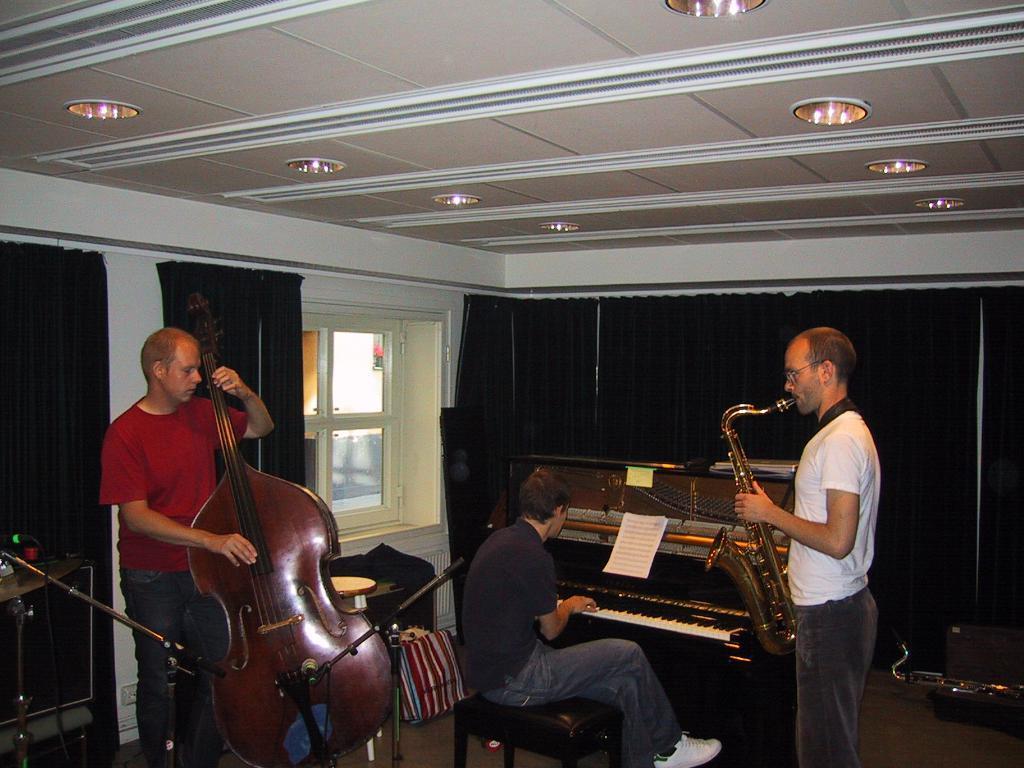How would you summarize this image in a sentence or two? In this image we can see three persons playing the musical instruments. We can also see the miles with the stands. Image also consists of the window, curtains, floor and also the ceiling with the ceiling lights. We can also see the papers and we can see the center person sitting. 